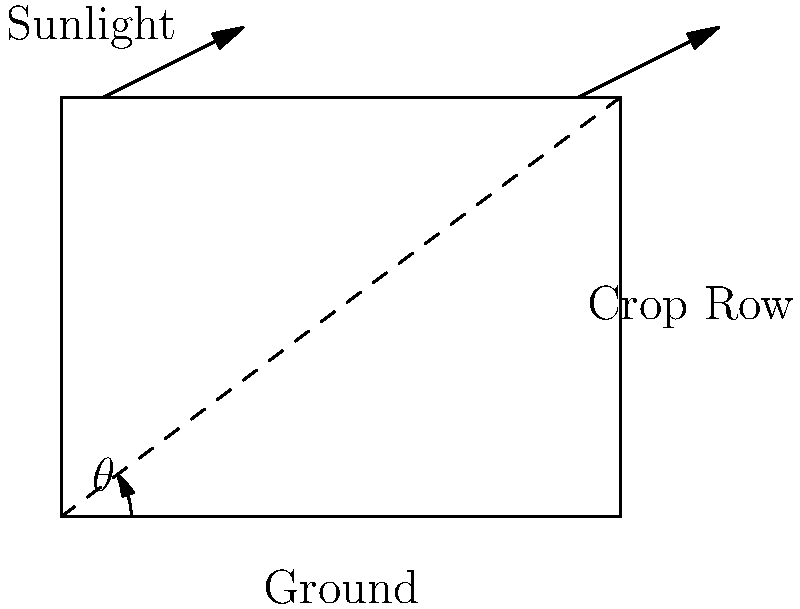You're planning to plant a new crop on a sloping field near the South Downs Way. To maximize sunlight exposure and minimize soil erosion, you need to determine the optimal angle $\theta$ between the crop rows and the ground. Given that the slope of the field is 30°, and the optimal angle for reducing soil erosion is typically 15° less than the slope angle, what should be the angle $\theta$ between your crop rows and the ground? Let's approach this step-by-step:

1) We're given that the slope of the field is 30°.

2) The optimal angle for reducing soil erosion is typically 15° less than the slope angle.

3) To calculate the optimal angle $\theta$:
   $\theta = \text{Slope angle} - 15°$
   $\theta = 30° - 15° = 15°$

4) This angle $\theta$ represents the angle between the crop rows and the horizontal ground.

5) By planting at this angle:
   - We reduce soil erosion by not planting directly down the slope.
   - We still allow for good sunlight exposure as the rows aren't perpendicular to the slope.

6) This arrangement allows water to flow more slowly down the slope, reducing erosion, while still maintaining good sun exposure for the crops.

Therefore, the optimal angle $\theta$ between your crop rows and the ground should be 15°.
Answer: $15°$ 